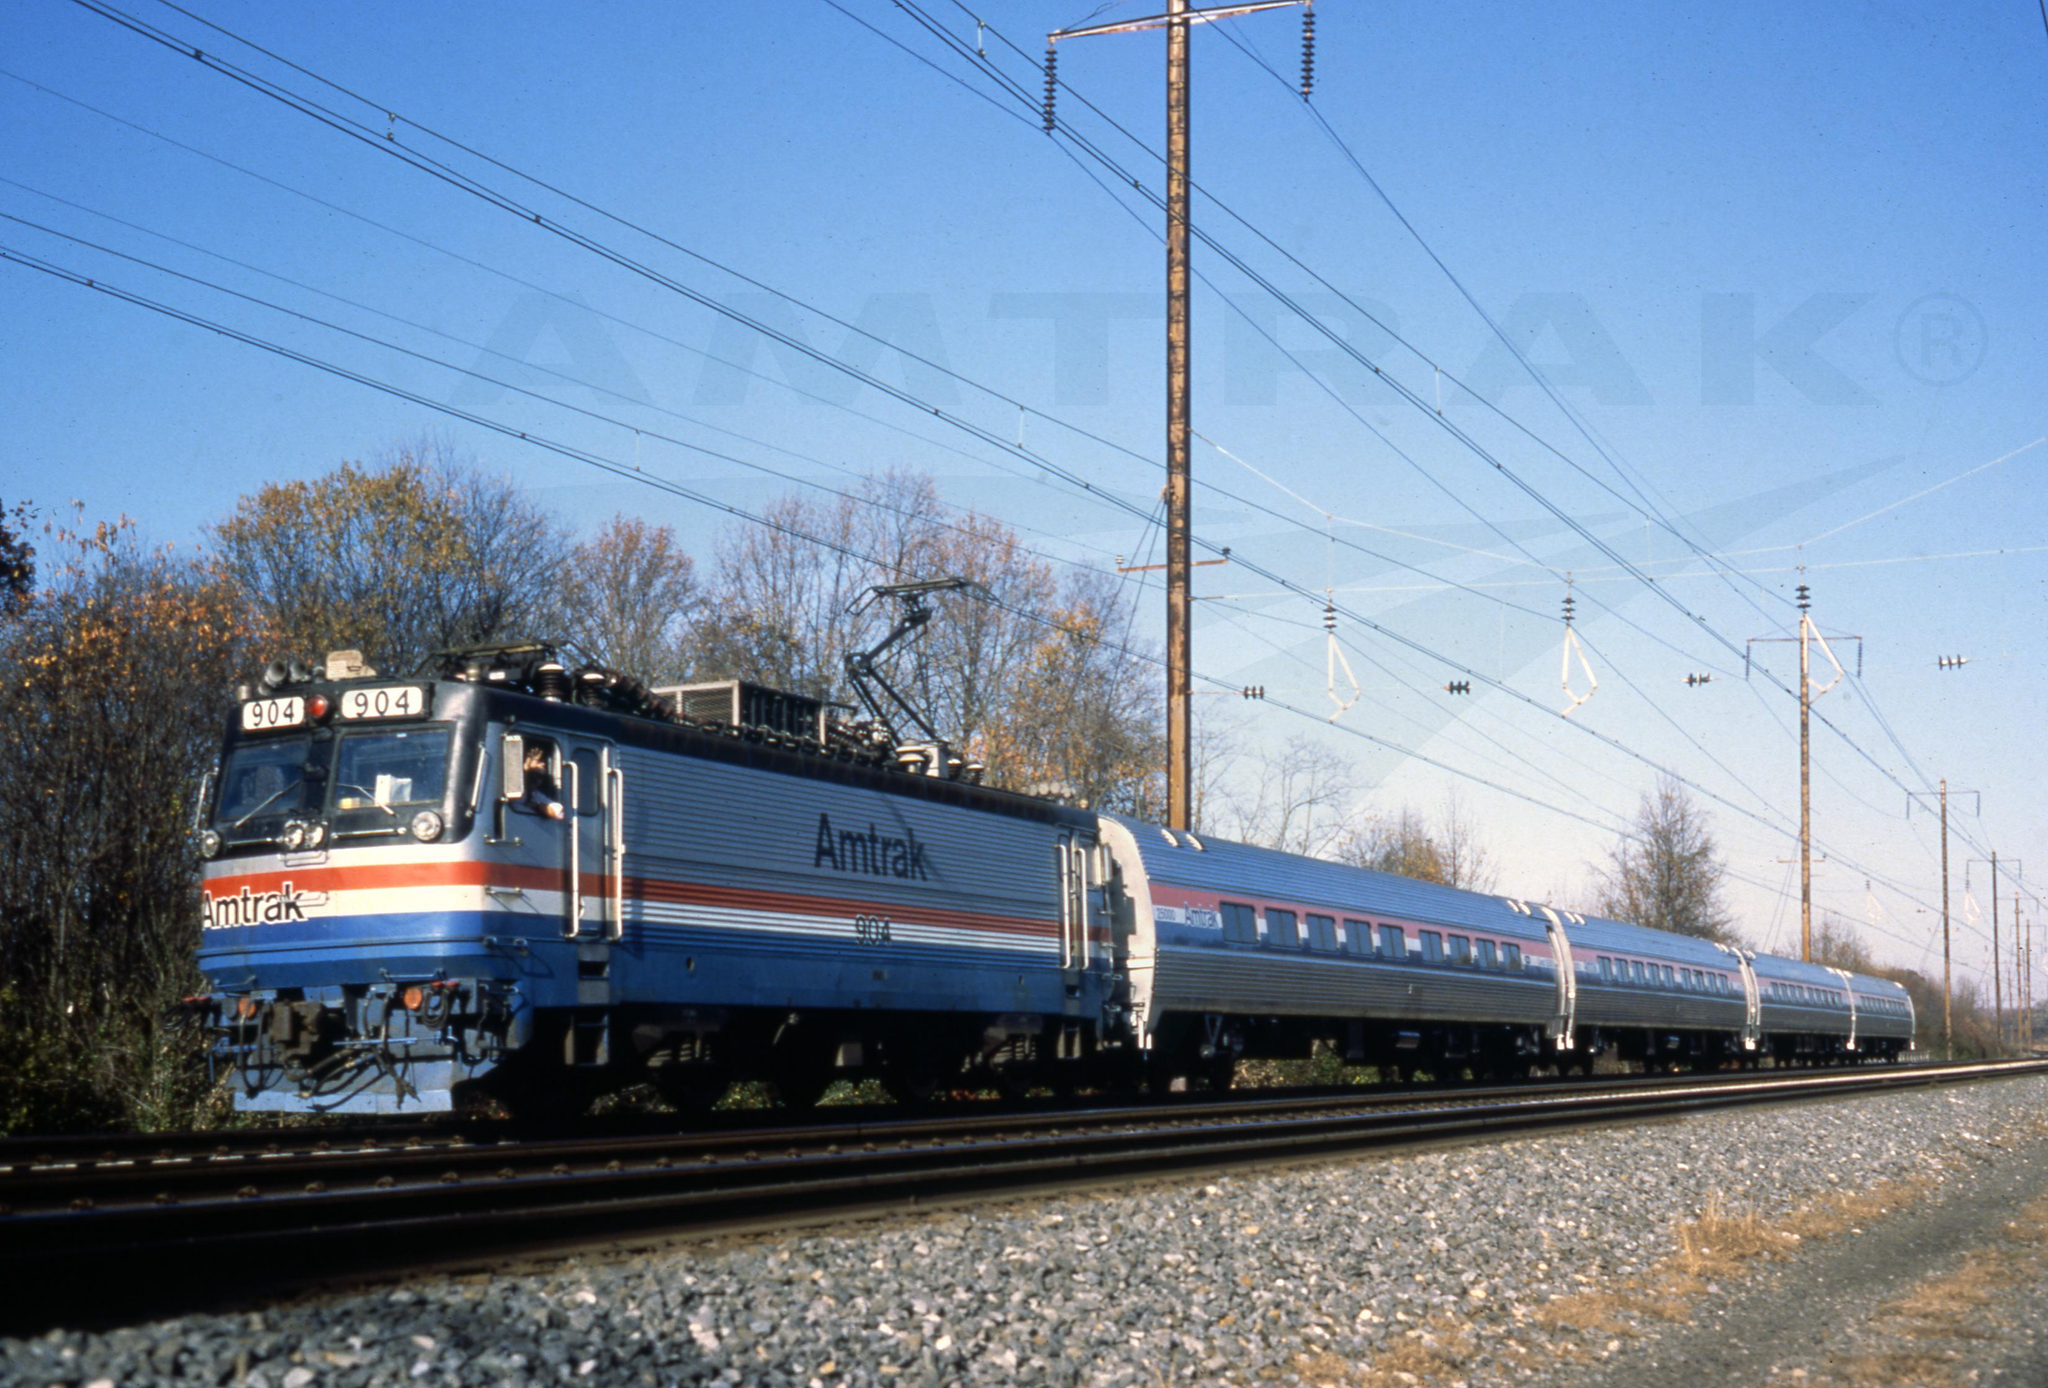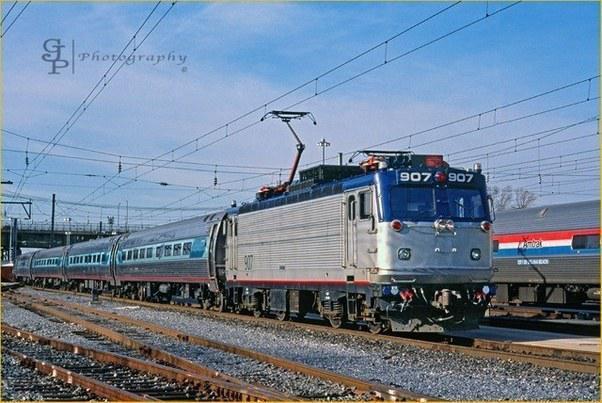The first image is the image on the left, the second image is the image on the right. Examine the images to the left and right. Is the description "The images show blue trains heading leftward." accurate? Answer yes or no. No. The first image is the image on the left, the second image is the image on the right. Analyze the images presented: Is the assertion "In the leftmost image the train is blue with red chinese lettering." valid? Answer yes or no. No. 